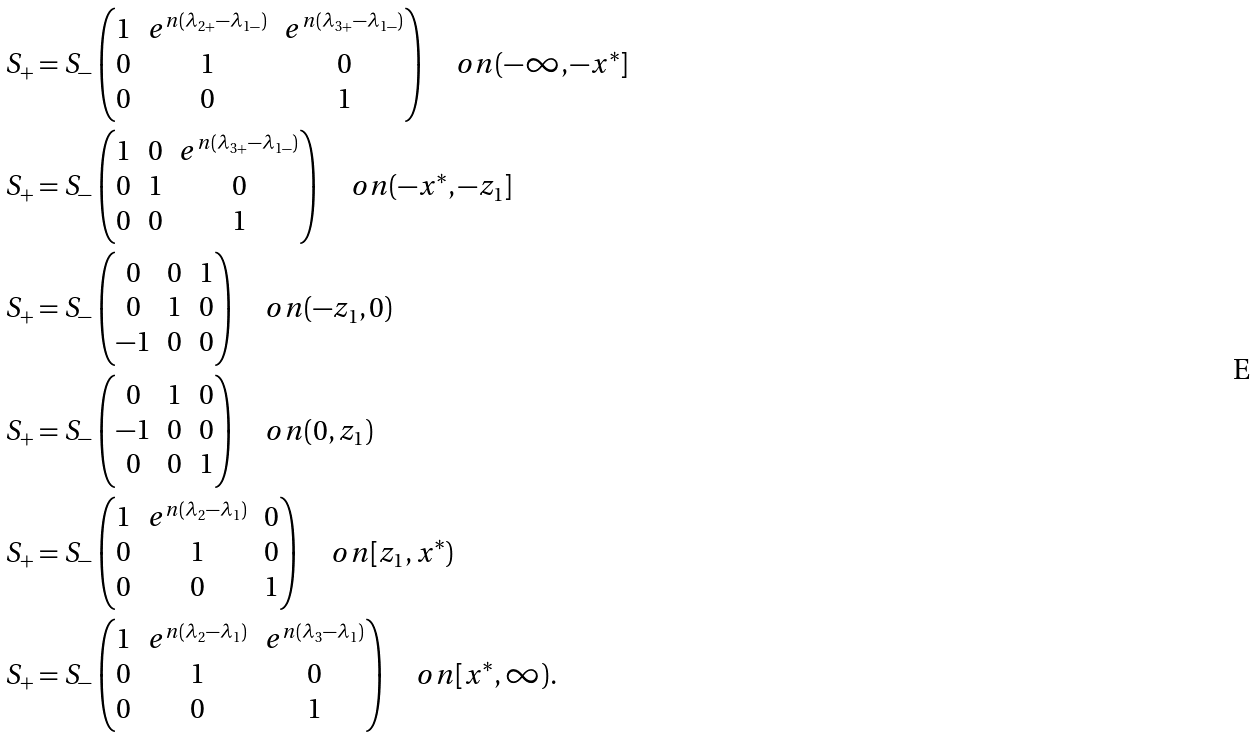<formula> <loc_0><loc_0><loc_500><loc_500>S _ { + } & = S _ { - } \begin{pmatrix} 1 & e ^ { n ( \lambda _ { 2 + } - \lambda _ { 1 - } ) } & e ^ { n ( \lambda _ { 3 + } - \lambda _ { 1 - } ) } \\ 0 & 1 & 0 \\ 0 & 0 & 1 \end{pmatrix} \quad o n ( - \infty , - x ^ { * } ] \\ S _ { + } & = S _ { - } \begin{pmatrix} 1 & 0 & e ^ { n ( \lambda _ { 3 + } - \lambda _ { 1 - } ) } \\ 0 & 1 & 0 \\ 0 & 0 & 1 \end{pmatrix} \quad o n ( - x ^ { * } , - z _ { 1 } ] \\ S _ { + } & = S _ { - } \begin{pmatrix} 0 & 0 & 1 \\ 0 & 1 & 0 \\ - 1 & 0 & 0 \end{pmatrix} \quad o n ( - z _ { 1 } , 0 ) \\ S _ { + } & = S _ { - } \begin{pmatrix} 0 & 1 & 0 \\ - 1 & 0 & 0 \\ 0 & 0 & 1 \end{pmatrix} \quad o n ( 0 , z _ { 1 } ) \\ S _ { + } & = S _ { - } \begin{pmatrix} 1 & e ^ { n ( \lambda _ { 2 } - \lambda _ { 1 } ) } & 0 \\ 0 & 1 & 0 \\ 0 & 0 & 1 \end{pmatrix} \quad o n [ z _ { 1 } , x ^ { * } ) \\ S _ { + } & = S _ { - } \begin{pmatrix} 1 & e ^ { n ( \lambda _ { 2 } - \lambda _ { 1 } ) } & e ^ { n ( \lambda _ { 3 } - \lambda _ { 1 } ) } \\ 0 & 1 & 0 \\ 0 & 0 & 1 \end{pmatrix} \quad o n [ x ^ { * } , \infty ) .</formula> 